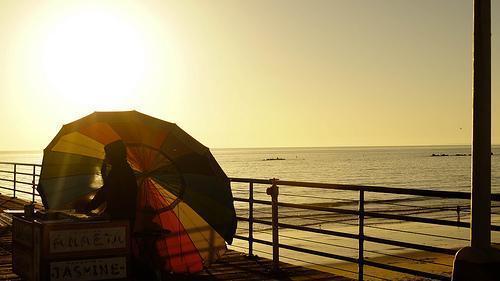How many people are on the beach?
Give a very brief answer. 0. How many kids are in the picture?
Give a very brief answer. 0. 